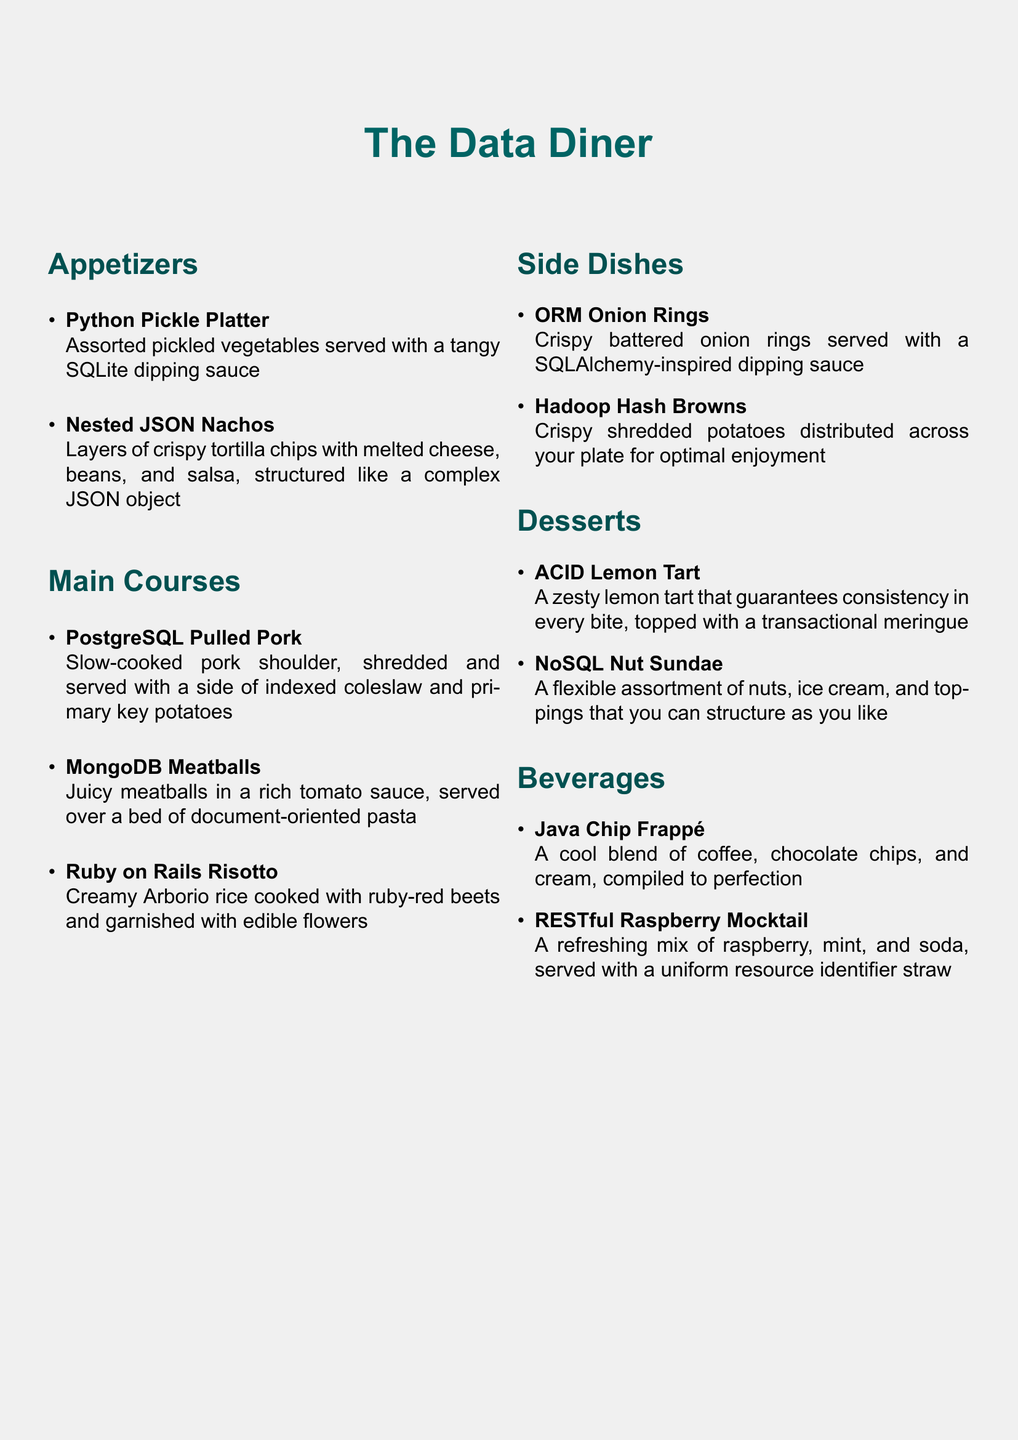What is the name of the appetizer featuring pickled vegetables? The appetizer featuring pickled vegetables is called "Python Pickle Platter."
Answer: Python Pickle Platter How many main courses are listed on the menu? The menu lists three main courses.
Answer: 3 What dish is served with a SQLAlchemy-inspired dipping sauce? The dish served with a SQLAlchemy-inspired dipping sauce is "ORM Onion Rings."
Answer: ORM Onion Rings What is the theme of the dessert named after a database concept? The dessert named after a database concept is "ACID Lemon Tart."
Answer: ACID Lemon Tart Which beverage is described as a mix of raspberry, mint, and soda? The beverage described as a mix of raspberry, mint, and soda is "RESTful Raspberry Mocktail."
Answer: RESTful Raspberry Mocktail What primary ingredient is used in "PostgreSQL Pulled Pork"? The primary ingredient used in "PostgreSQL Pulled Pork" is pork shoulder.
Answer: pork shoulder How are the "Nested JSON Nachos" structured? The "Nested JSON Nachos" are structured like a complex JSON object.
Answer: complex JSON object What type of dish is "MongoDB Meatballs"? "MongoDB Meatballs" is a main course.
Answer: main course What kind of potatoes are served with "PostgreSQL Pulled Pork"? The kind of potatoes served with "PostgreSQL Pulled Pork" are "primary key potatoes."
Answer: primary key potatoes 